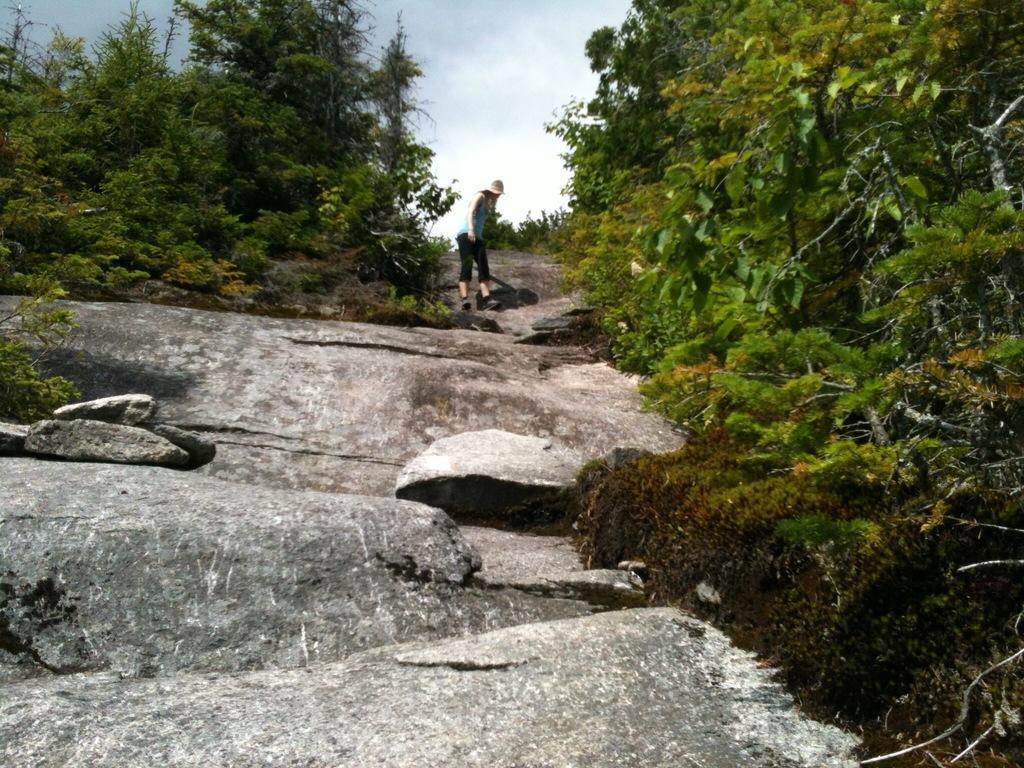How would you summarize this image in a sentence or two? There are trees, a person is standing, this is sky. 